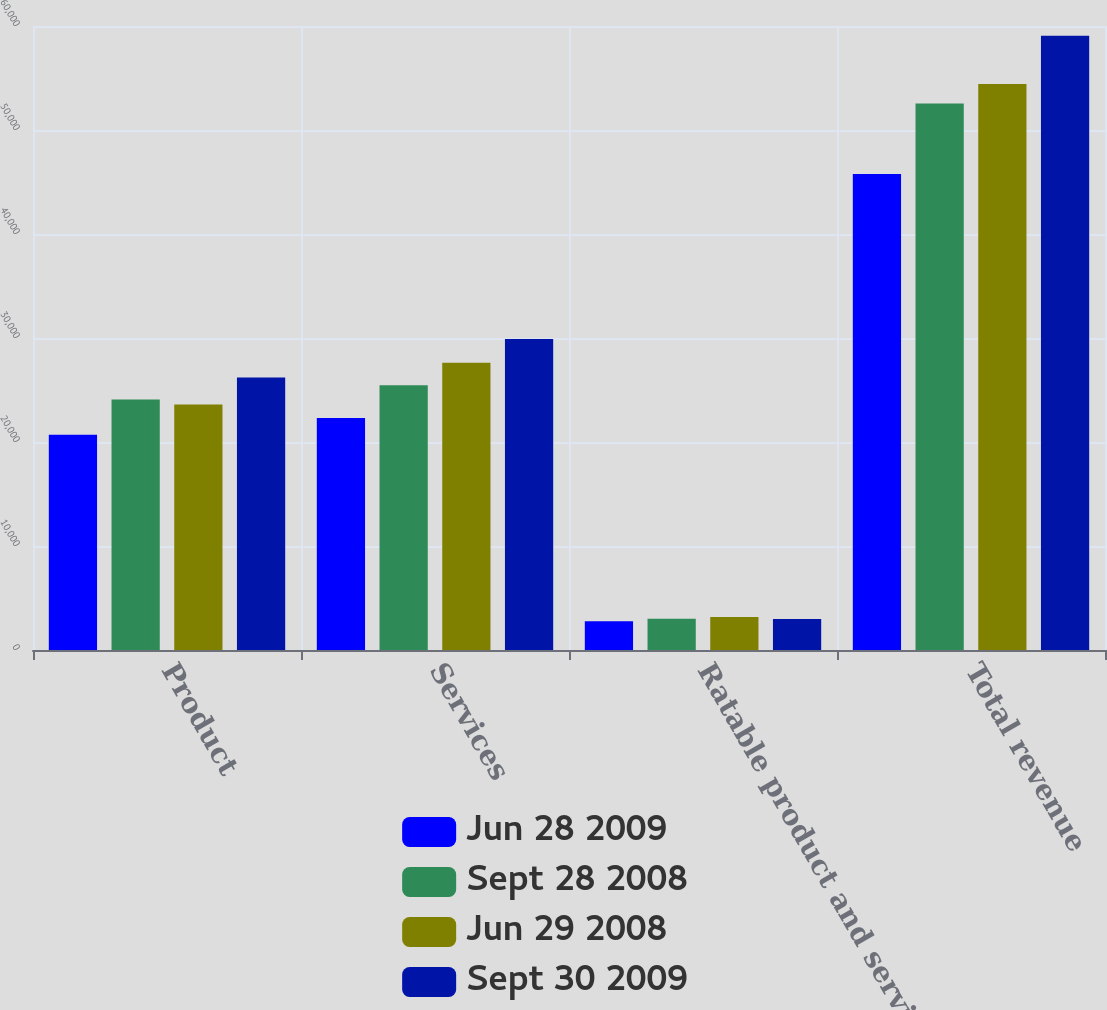<chart> <loc_0><loc_0><loc_500><loc_500><stacked_bar_chart><ecel><fcel>Product<fcel>Services<fcel>Ratable product and services<fcel>Total revenue<nl><fcel>Jun 28 2009<fcel>20691<fcel>22312<fcel>2761<fcel>45764<nl><fcel>Sept 28 2008<fcel>24088<fcel>25455<fcel>3004<fcel>52547<nl><fcel>Jun 29 2008<fcel>23616<fcel>27627<fcel>3171<fcel>54414<nl><fcel>Sept 30 2009<fcel>26192<fcel>29898<fcel>2976<fcel>59066<nl></chart> 